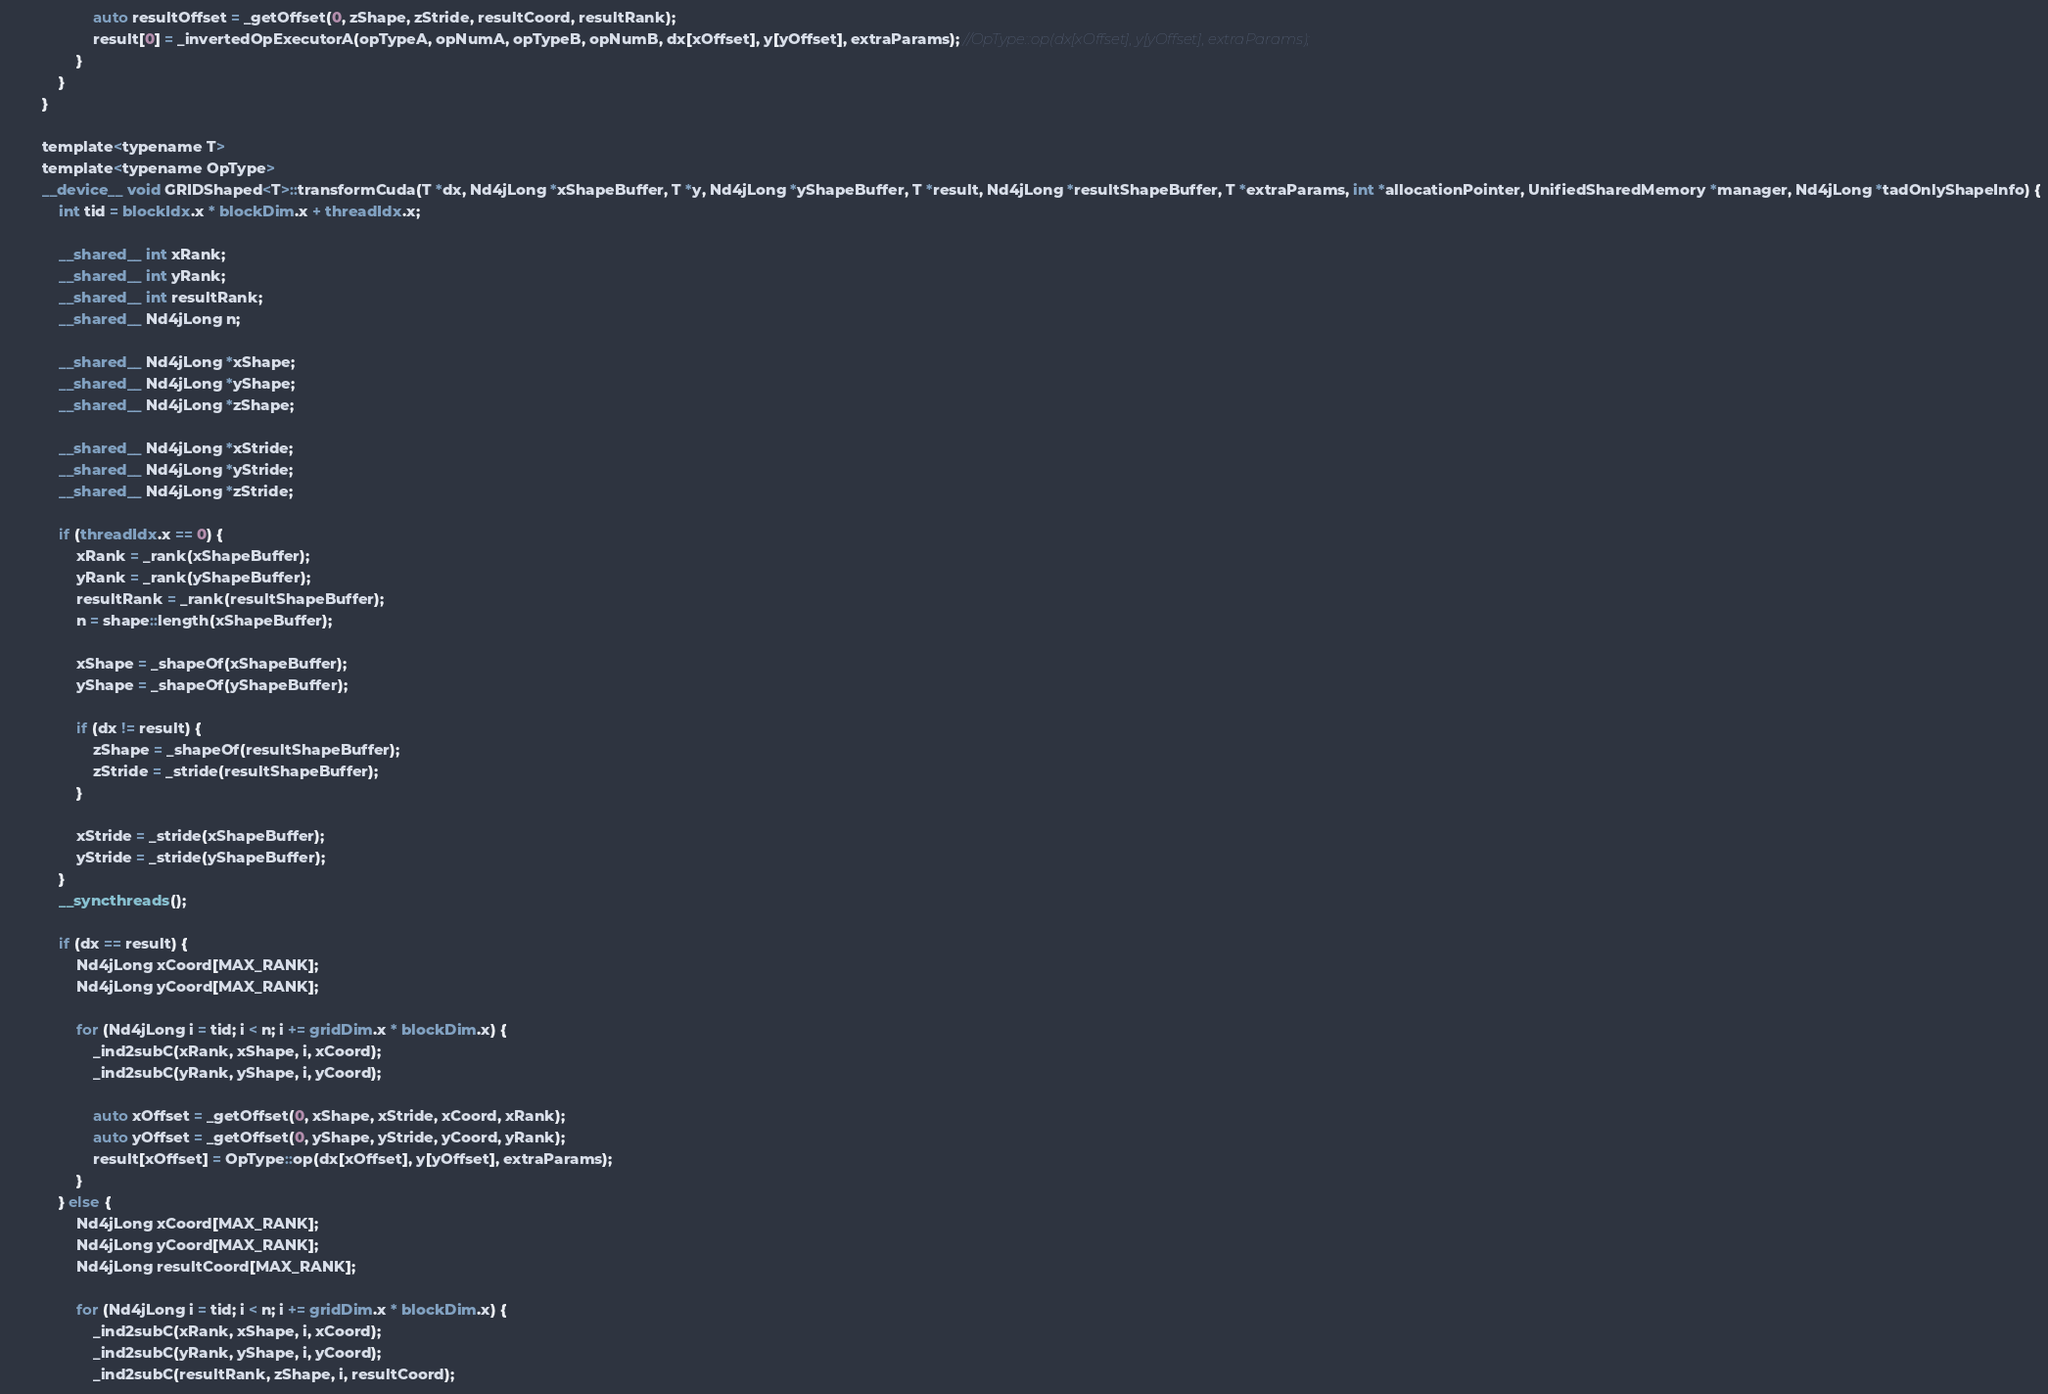Convert code to text. <code><loc_0><loc_0><loc_500><loc_500><_Cuda_>                    auto resultOffset = _getOffset(0, zShape, zStride, resultCoord, resultRank);
                    result[0] = _invertedOpExecutorA(opTypeA, opNumA, opTypeB, opNumB, dx[xOffset], y[yOffset], extraParams); //OpType::op(dx[xOffset], y[yOffset], extraParams);
                }
            }
        }

        template<typename T>
        template<typename OpType>
        __device__ void GRIDShaped<T>::transformCuda(T *dx, Nd4jLong *xShapeBuffer, T *y, Nd4jLong *yShapeBuffer, T *result, Nd4jLong *resultShapeBuffer, T *extraParams, int *allocationPointer, UnifiedSharedMemory *manager, Nd4jLong *tadOnlyShapeInfo) {
            int tid = blockIdx.x * blockDim.x + threadIdx.x;

            __shared__ int xRank;
            __shared__ int yRank;
            __shared__ int resultRank;
            __shared__ Nd4jLong n;

            __shared__ Nd4jLong *xShape;
            __shared__ Nd4jLong *yShape;
            __shared__ Nd4jLong *zShape;

            __shared__ Nd4jLong *xStride;
            __shared__ Nd4jLong *yStride;
            __shared__ Nd4jLong *zStride;

            if (threadIdx.x == 0) {
                xRank = _rank(xShapeBuffer);
                yRank = _rank(yShapeBuffer);
                resultRank = _rank(resultShapeBuffer);
                n = shape::length(xShapeBuffer);

                xShape = _shapeOf(xShapeBuffer);
                yShape = _shapeOf(yShapeBuffer);

                if (dx != result) {
                    zShape = _shapeOf(resultShapeBuffer);
                    zStride = _stride(resultShapeBuffer);
                }

                xStride = _stride(xShapeBuffer);
                yStride = _stride(yShapeBuffer);
            }
            __syncthreads();

            if (dx == result) {
                Nd4jLong xCoord[MAX_RANK];
                Nd4jLong yCoord[MAX_RANK];

                for (Nd4jLong i = tid; i < n; i += gridDim.x * blockDim.x) {
                    _ind2subC(xRank, xShape, i, xCoord);
                    _ind2subC(yRank, yShape, i, yCoord);

                    auto xOffset = _getOffset(0, xShape, xStride, xCoord, xRank);
                    auto yOffset = _getOffset(0, yShape, yStride, yCoord, yRank);
                    result[xOffset] = OpType::op(dx[xOffset], y[yOffset], extraParams);
                }
            } else {
                Nd4jLong xCoord[MAX_RANK];
                Nd4jLong yCoord[MAX_RANK];
                Nd4jLong resultCoord[MAX_RANK];

                for (Nd4jLong i = tid; i < n; i += gridDim.x * blockDim.x) {
                    _ind2subC(xRank, xShape, i, xCoord);
                    _ind2subC(yRank, yShape, i, yCoord);
                    _ind2subC(resultRank, zShape, i, resultCoord);
</code> 